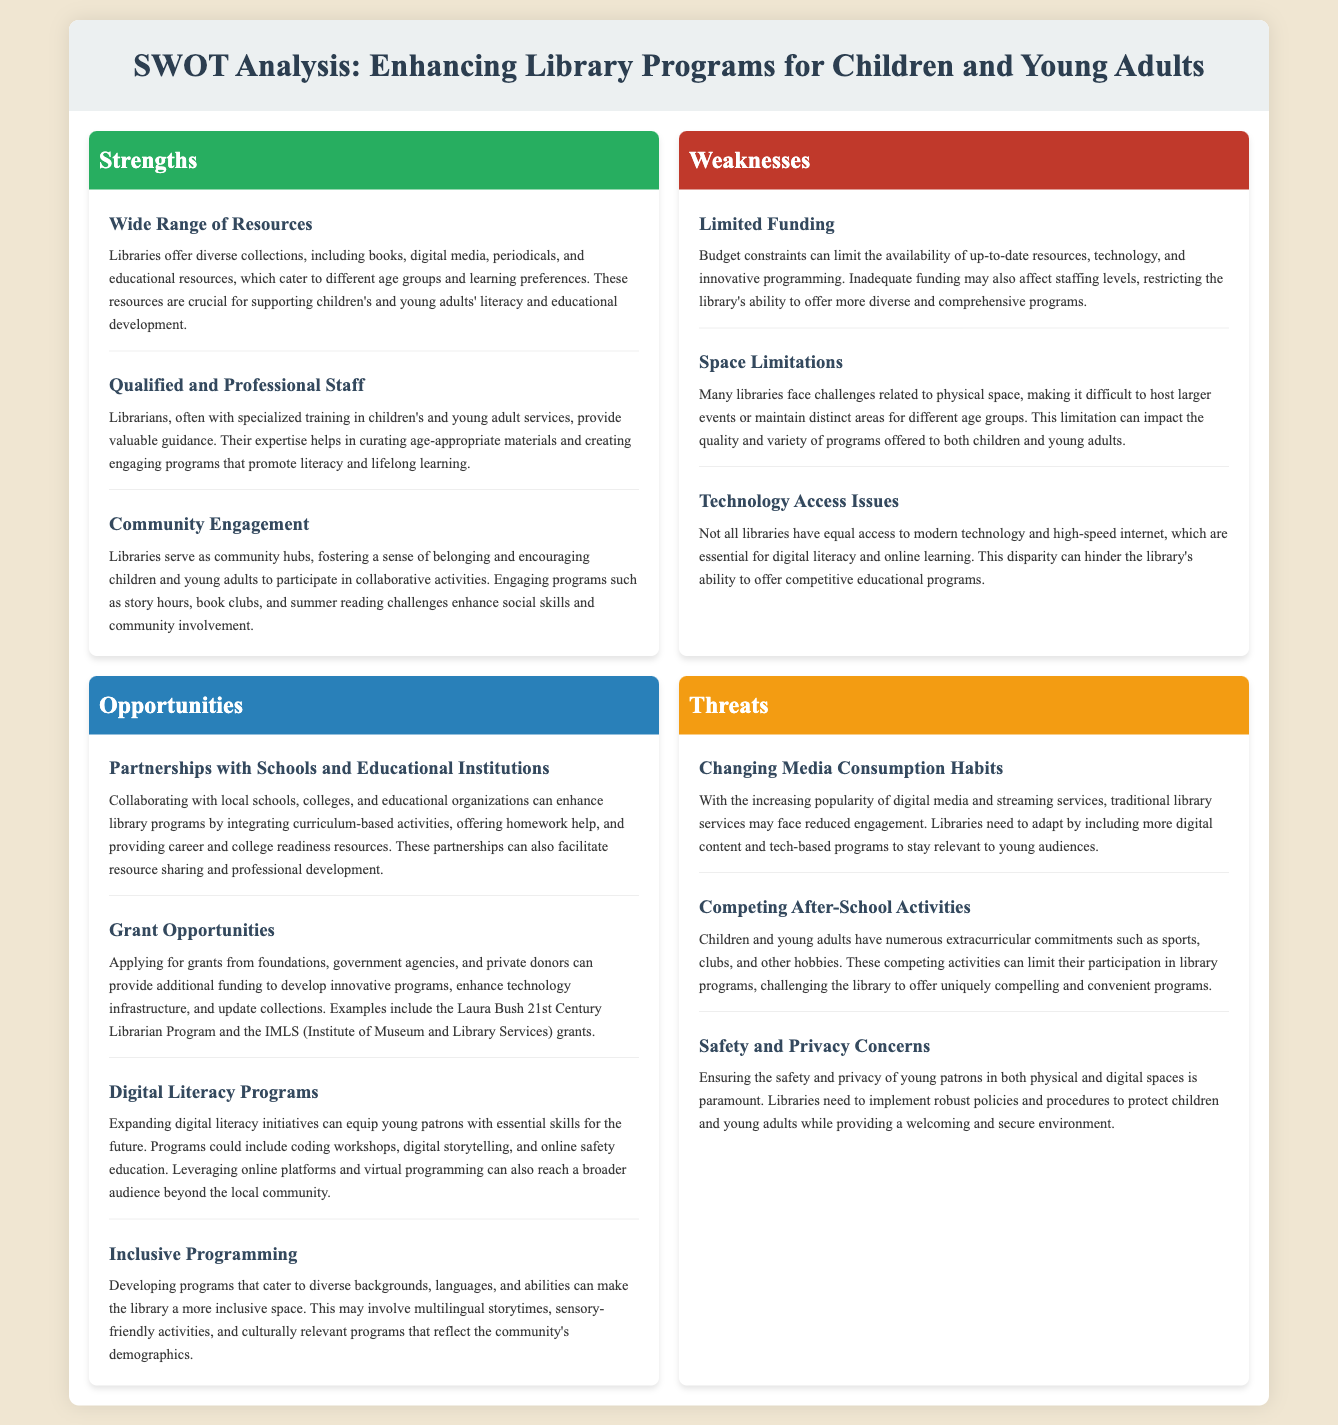What is one strength mentioned in the document? The document lists multiple strengths, including "Wide Range of Resources," which highlights the variety of materials libraries provide.
Answer: Wide Range of Resources What is a weakness related to funding? The document specifies "Limited Funding" as a weakness, indicating budget constraints that affect library resources.
Answer: Limited Funding What type of program is suggested as an opportunity for enhancing library services? The document mentions "Digital Literacy Programs" as an opportunity that can equip young patrons with essential skills.
Answer: Digital Literacy Programs How many strengths are listed in the document? By counting the specific elements in the strengths section, we find there are three strengths mentioned.
Answer: 3 What is one threat libraries face according to the analysis? The document identifies "Changing Media Consumption Habits" as a threat impacting library engagement.
Answer: Changing Media Consumption Habits What is one of the opportunities for collaboration mentioned in the document? The document discusses "Partnerships with Schools and Educational Institutions" as a means to enhance library programs.
Answer: Partnerships with Schools and Educational Institutions What aspect of programming is emphasized for inclusivity? The analysis highlights "Inclusive Programming" as a key approach to cater to diverse backgrounds and needs of the community.
Answer: Inclusive Programming What is the focus of the threat related to safety? The document states that "Safety and Privacy Concerns" are crucial considerations for libraries regarding young patrons.
Answer: Safety and Privacy Concerns 